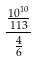Convert formula to latex. <formula><loc_0><loc_0><loc_500><loc_500>\frac { \frac { 1 0 ^ { 1 0 } } { 1 1 3 } } { \frac { 4 } { 6 } }</formula> 